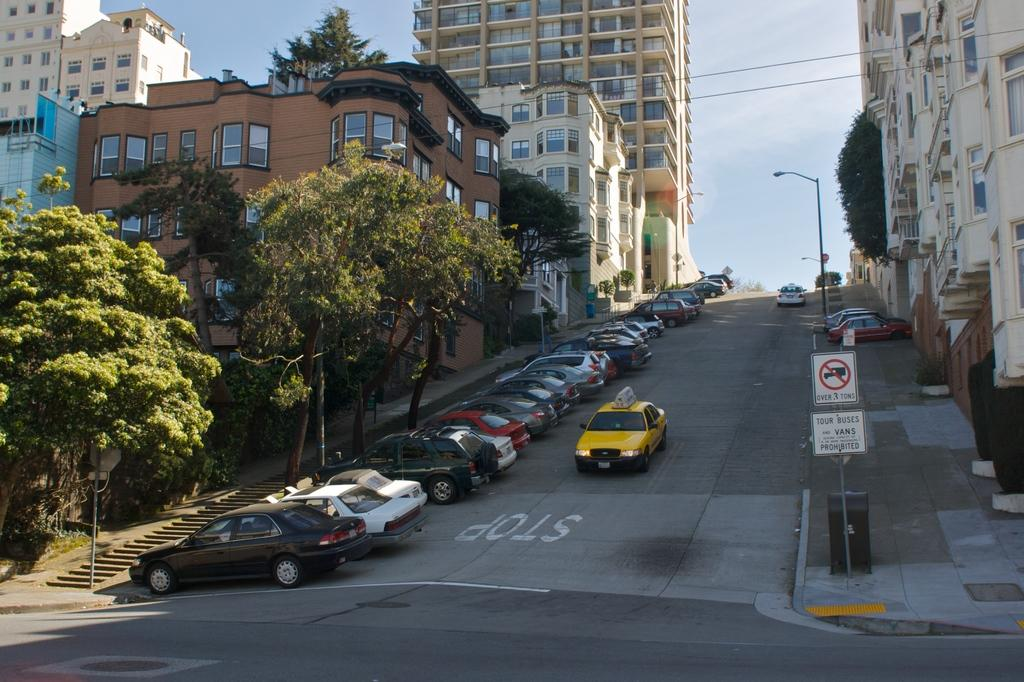Provide a one-sentence caption for the provided image. A Taxi going down a big hill in a dense suburban street that says Stop. 